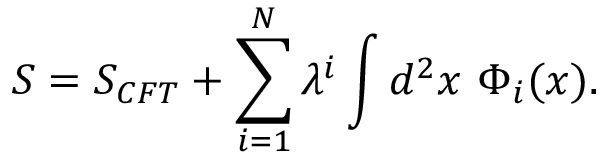Convert formula to latex. <formula><loc_0><loc_0><loc_500><loc_500>S = S _ { C F T } + \sum _ { i = 1 } ^ { N } \lambda ^ { i } \int d ^ { 2 } x \ \Phi _ { i } ( x ) .</formula> 